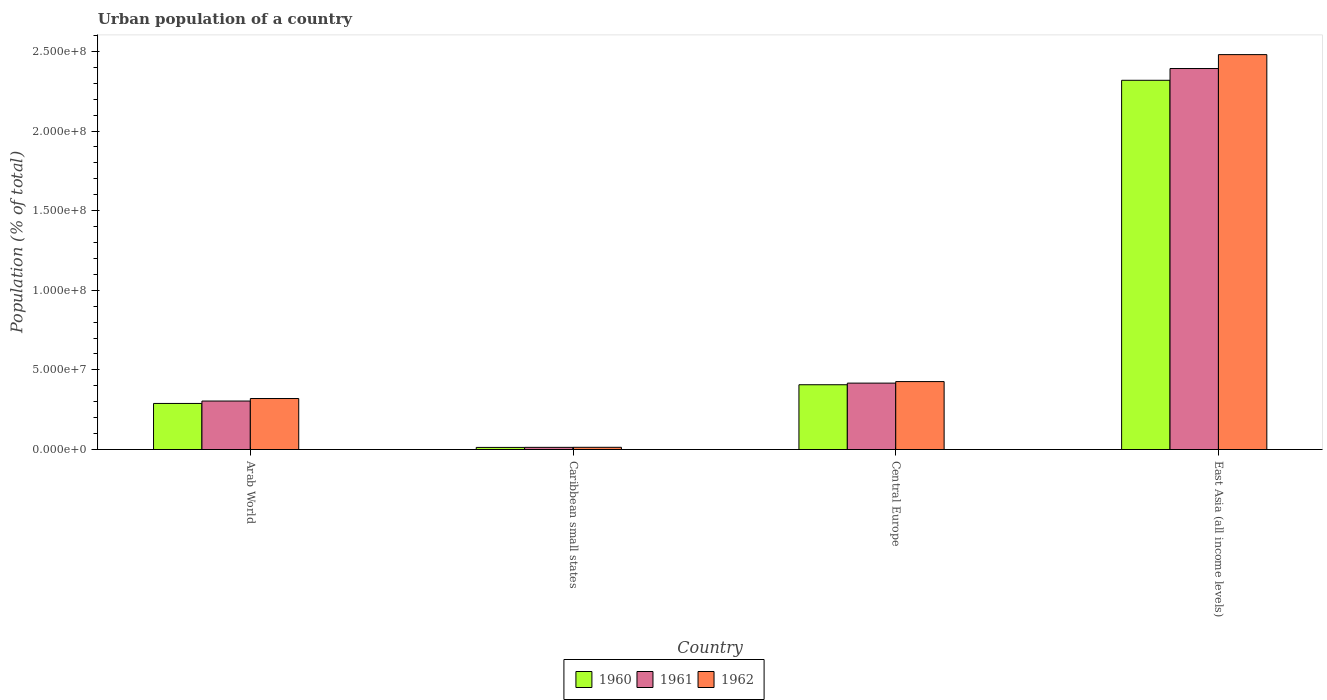How many different coloured bars are there?
Give a very brief answer. 3. How many groups of bars are there?
Your response must be concise. 4. What is the label of the 2nd group of bars from the left?
Offer a very short reply. Caribbean small states. In how many cases, is the number of bars for a given country not equal to the number of legend labels?
Your answer should be very brief. 0. What is the urban population in 1961 in East Asia (all income levels)?
Ensure brevity in your answer.  2.39e+08. Across all countries, what is the maximum urban population in 1962?
Your answer should be very brief. 2.48e+08. Across all countries, what is the minimum urban population in 1962?
Your response must be concise. 1.40e+06. In which country was the urban population in 1962 maximum?
Your answer should be compact. East Asia (all income levels). In which country was the urban population in 1961 minimum?
Your answer should be very brief. Caribbean small states. What is the total urban population in 1962 in the graph?
Provide a short and direct response. 3.24e+08. What is the difference between the urban population in 1960 in Arab World and that in East Asia (all income levels)?
Keep it short and to the point. -2.03e+08. What is the difference between the urban population in 1960 in Central Europe and the urban population in 1961 in Arab World?
Your response must be concise. 1.02e+07. What is the average urban population in 1961 per country?
Ensure brevity in your answer.  7.82e+07. What is the difference between the urban population of/in 1961 and urban population of/in 1962 in East Asia (all income levels)?
Your response must be concise. -8.73e+06. In how many countries, is the urban population in 1961 greater than 30000000 %?
Make the answer very short. 3. What is the ratio of the urban population in 1961 in Arab World to that in Central Europe?
Your response must be concise. 0.73. Is the difference between the urban population in 1961 in Arab World and Central Europe greater than the difference between the urban population in 1962 in Arab World and Central Europe?
Your answer should be very brief. No. What is the difference between the highest and the second highest urban population in 1961?
Keep it short and to the point. -1.13e+07. What is the difference between the highest and the lowest urban population in 1961?
Offer a very short reply. 2.38e+08. Is the sum of the urban population in 1960 in Arab World and East Asia (all income levels) greater than the maximum urban population in 1961 across all countries?
Your response must be concise. Yes. What does the 3rd bar from the right in Arab World represents?
Your response must be concise. 1960. Are all the bars in the graph horizontal?
Give a very brief answer. No. What is the difference between two consecutive major ticks on the Y-axis?
Provide a succinct answer. 5.00e+07. Are the values on the major ticks of Y-axis written in scientific E-notation?
Offer a very short reply. Yes. Does the graph contain grids?
Give a very brief answer. No. Where does the legend appear in the graph?
Your answer should be compact. Bottom center. What is the title of the graph?
Your answer should be very brief. Urban population of a country. What is the label or title of the Y-axis?
Your answer should be compact. Population (% of total). What is the Population (% of total) of 1960 in Arab World?
Provide a succinct answer. 2.89e+07. What is the Population (% of total) of 1961 in Arab World?
Offer a very short reply. 3.04e+07. What is the Population (% of total) of 1962 in Arab World?
Offer a terse response. 3.20e+07. What is the Population (% of total) in 1960 in Caribbean small states?
Your response must be concise. 1.32e+06. What is the Population (% of total) in 1961 in Caribbean small states?
Ensure brevity in your answer.  1.36e+06. What is the Population (% of total) in 1962 in Caribbean small states?
Make the answer very short. 1.40e+06. What is the Population (% of total) of 1960 in Central Europe?
Ensure brevity in your answer.  4.07e+07. What is the Population (% of total) of 1961 in Central Europe?
Your answer should be compact. 4.17e+07. What is the Population (% of total) of 1962 in Central Europe?
Keep it short and to the point. 4.27e+07. What is the Population (% of total) in 1960 in East Asia (all income levels)?
Offer a terse response. 2.32e+08. What is the Population (% of total) in 1961 in East Asia (all income levels)?
Provide a succinct answer. 2.39e+08. What is the Population (% of total) in 1962 in East Asia (all income levels)?
Make the answer very short. 2.48e+08. Across all countries, what is the maximum Population (% of total) of 1960?
Provide a succinct answer. 2.32e+08. Across all countries, what is the maximum Population (% of total) in 1961?
Ensure brevity in your answer.  2.39e+08. Across all countries, what is the maximum Population (% of total) of 1962?
Offer a terse response. 2.48e+08. Across all countries, what is the minimum Population (% of total) of 1960?
Provide a short and direct response. 1.32e+06. Across all countries, what is the minimum Population (% of total) of 1961?
Give a very brief answer. 1.36e+06. Across all countries, what is the minimum Population (% of total) of 1962?
Give a very brief answer. 1.40e+06. What is the total Population (% of total) of 1960 in the graph?
Make the answer very short. 3.03e+08. What is the total Population (% of total) in 1961 in the graph?
Offer a very short reply. 3.13e+08. What is the total Population (% of total) in 1962 in the graph?
Give a very brief answer. 3.24e+08. What is the difference between the Population (% of total) of 1960 in Arab World and that in Caribbean small states?
Provide a short and direct response. 2.76e+07. What is the difference between the Population (% of total) of 1961 in Arab World and that in Caribbean small states?
Ensure brevity in your answer.  2.91e+07. What is the difference between the Population (% of total) in 1962 in Arab World and that in Caribbean small states?
Your response must be concise. 3.06e+07. What is the difference between the Population (% of total) in 1960 in Arab World and that in Central Europe?
Ensure brevity in your answer.  -1.17e+07. What is the difference between the Population (% of total) of 1961 in Arab World and that in Central Europe?
Offer a very short reply. -1.13e+07. What is the difference between the Population (% of total) of 1962 in Arab World and that in Central Europe?
Your answer should be compact. -1.06e+07. What is the difference between the Population (% of total) of 1960 in Arab World and that in East Asia (all income levels)?
Give a very brief answer. -2.03e+08. What is the difference between the Population (% of total) of 1961 in Arab World and that in East Asia (all income levels)?
Provide a short and direct response. -2.09e+08. What is the difference between the Population (% of total) of 1962 in Arab World and that in East Asia (all income levels)?
Ensure brevity in your answer.  -2.16e+08. What is the difference between the Population (% of total) of 1960 in Caribbean small states and that in Central Europe?
Keep it short and to the point. -3.94e+07. What is the difference between the Population (% of total) of 1961 in Caribbean small states and that in Central Europe?
Your answer should be compact. -4.03e+07. What is the difference between the Population (% of total) in 1962 in Caribbean small states and that in Central Europe?
Offer a very short reply. -4.13e+07. What is the difference between the Population (% of total) of 1960 in Caribbean small states and that in East Asia (all income levels)?
Offer a very short reply. -2.31e+08. What is the difference between the Population (% of total) in 1961 in Caribbean small states and that in East Asia (all income levels)?
Keep it short and to the point. -2.38e+08. What is the difference between the Population (% of total) in 1962 in Caribbean small states and that in East Asia (all income levels)?
Give a very brief answer. -2.47e+08. What is the difference between the Population (% of total) of 1960 in Central Europe and that in East Asia (all income levels)?
Give a very brief answer. -1.91e+08. What is the difference between the Population (% of total) of 1961 in Central Europe and that in East Asia (all income levels)?
Keep it short and to the point. -1.98e+08. What is the difference between the Population (% of total) in 1962 in Central Europe and that in East Asia (all income levels)?
Provide a short and direct response. -2.05e+08. What is the difference between the Population (% of total) in 1960 in Arab World and the Population (% of total) in 1961 in Caribbean small states?
Make the answer very short. 2.76e+07. What is the difference between the Population (% of total) of 1960 in Arab World and the Population (% of total) of 1962 in Caribbean small states?
Ensure brevity in your answer.  2.75e+07. What is the difference between the Population (% of total) of 1961 in Arab World and the Population (% of total) of 1962 in Caribbean small states?
Offer a very short reply. 2.90e+07. What is the difference between the Population (% of total) in 1960 in Arab World and the Population (% of total) in 1961 in Central Europe?
Provide a short and direct response. -1.28e+07. What is the difference between the Population (% of total) of 1960 in Arab World and the Population (% of total) of 1962 in Central Europe?
Your answer should be compact. -1.37e+07. What is the difference between the Population (% of total) in 1961 in Arab World and the Population (% of total) in 1962 in Central Europe?
Provide a short and direct response. -1.22e+07. What is the difference between the Population (% of total) in 1960 in Arab World and the Population (% of total) in 1961 in East Asia (all income levels)?
Offer a very short reply. -2.10e+08. What is the difference between the Population (% of total) of 1960 in Arab World and the Population (% of total) of 1962 in East Asia (all income levels)?
Provide a succinct answer. -2.19e+08. What is the difference between the Population (% of total) of 1961 in Arab World and the Population (% of total) of 1962 in East Asia (all income levels)?
Offer a very short reply. -2.18e+08. What is the difference between the Population (% of total) in 1960 in Caribbean small states and the Population (% of total) in 1961 in Central Europe?
Your response must be concise. -4.04e+07. What is the difference between the Population (% of total) in 1960 in Caribbean small states and the Population (% of total) in 1962 in Central Europe?
Offer a terse response. -4.13e+07. What is the difference between the Population (% of total) of 1961 in Caribbean small states and the Population (% of total) of 1962 in Central Europe?
Offer a very short reply. -4.13e+07. What is the difference between the Population (% of total) of 1960 in Caribbean small states and the Population (% of total) of 1961 in East Asia (all income levels)?
Give a very brief answer. -2.38e+08. What is the difference between the Population (% of total) in 1960 in Caribbean small states and the Population (% of total) in 1962 in East Asia (all income levels)?
Provide a succinct answer. -2.47e+08. What is the difference between the Population (% of total) in 1961 in Caribbean small states and the Population (% of total) in 1962 in East Asia (all income levels)?
Give a very brief answer. -2.47e+08. What is the difference between the Population (% of total) of 1960 in Central Europe and the Population (% of total) of 1961 in East Asia (all income levels)?
Offer a terse response. -1.99e+08. What is the difference between the Population (% of total) of 1960 in Central Europe and the Population (% of total) of 1962 in East Asia (all income levels)?
Provide a short and direct response. -2.07e+08. What is the difference between the Population (% of total) in 1961 in Central Europe and the Population (% of total) in 1962 in East Asia (all income levels)?
Provide a succinct answer. -2.06e+08. What is the average Population (% of total) in 1960 per country?
Your response must be concise. 7.57e+07. What is the average Population (% of total) in 1961 per country?
Make the answer very short. 7.82e+07. What is the average Population (% of total) of 1962 per country?
Offer a very short reply. 8.10e+07. What is the difference between the Population (% of total) of 1960 and Population (% of total) of 1961 in Arab World?
Offer a terse response. -1.50e+06. What is the difference between the Population (% of total) in 1960 and Population (% of total) in 1962 in Arab World?
Provide a succinct answer. -3.09e+06. What is the difference between the Population (% of total) of 1961 and Population (% of total) of 1962 in Arab World?
Your response must be concise. -1.58e+06. What is the difference between the Population (% of total) in 1960 and Population (% of total) in 1961 in Caribbean small states?
Ensure brevity in your answer.  -3.48e+04. What is the difference between the Population (% of total) of 1960 and Population (% of total) of 1962 in Caribbean small states?
Ensure brevity in your answer.  -7.14e+04. What is the difference between the Population (% of total) in 1961 and Population (% of total) in 1962 in Caribbean small states?
Offer a terse response. -3.66e+04. What is the difference between the Population (% of total) of 1960 and Population (% of total) of 1961 in Central Europe?
Your response must be concise. -1.02e+06. What is the difference between the Population (% of total) in 1960 and Population (% of total) in 1962 in Central Europe?
Your answer should be very brief. -1.98e+06. What is the difference between the Population (% of total) in 1961 and Population (% of total) in 1962 in Central Europe?
Keep it short and to the point. -9.65e+05. What is the difference between the Population (% of total) of 1960 and Population (% of total) of 1961 in East Asia (all income levels)?
Provide a short and direct response. -7.39e+06. What is the difference between the Population (% of total) in 1960 and Population (% of total) in 1962 in East Asia (all income levels)?
Provide a succinct answer. -1.61e+07. What is the difference between the Population (% of total) in 1961 and Population (% of total) in 1962 in East Asia (all income levels)?
Your answer should be compact. -8.73e+06. What is the ratio of the Population (% of total) in 1960 in Arab World to that in Caribbean small states?
Your answer should be compact. 21.85. What is the ratio of the Population (% of total) in 1961 in Arab World to that in Caribbean small states?
Provide a succinct answer. 22.4. What is the ratio of the Population (% of total) in 1962 in Arab World to that in Caribbean small states?
Your answer should be very brief. 22.95. What is the ratio of the Population (% of total) of 1960 in Arab World to that in Central Europe?
Your response must be concise. 0.71. What is the ratio of the Population (% of total) in 1961 in Arab World to that in Central Europe?
Offer a very short reply. 0.73. What is the ratio of the Population (% of total) in 1962 in Arab World to that in Central Europe?
Your response must be concise. 0.75. What is the ratio of the Population (% of total) in 1960 in Arab World to that in East Asia (all income levels)?
Provide a short and direct response. 0.12. What is the ratio of the Population (% of total) of 1961 in Arab World to that in East Asia (all income levels)?
Your response must be concise. 0.13. What is the ratio of the Population (% of total) of 1962 in Arab World to that in East Asia (all income levels)?
Your answer should be very brief. 0.13. What is the ratio of the Population (% of total) of 1960 in Caribbean small states to that in Central Europe?
Keep it short and to the point. 0.03. What is the ratio of the Population (% of total) in 1961 in Caribbean small states to that in Central Europe?
Your response must be concise. 0.03. What is the ratio of the Population (% of total) of 1962 in Caribbean small states to that in Central Europe?
Your answer should be compact. 0.03. What is the ratio of the Population (% of total) of 1960 in Caribbean small states to that in East Asia (all income levels)?
Provide a succinct answer. 0.01. What is the ratio of the Population (% of total) in 1961 in Caribbean small states to that in East Asia (all income levels)?
Provide a succinct answer. 0.01. What is the ratio of the Population (% of total) in 1962 in Caribbean small states to that in East Asia (all income levels)?
Provide a succinct answer. 0.01. What is the ratio of the Population (% of total) in 1960 in Central Europe to that in East Asia (all income levels)?
Your response must be concise. 0.18. What is the ratio of the Population (% of total) in 1961 in Central Europe to that in East Asia (all income levels)?
Ensure brevity in your answer.  0.17. What is the ratio of the Population (% of total) of 1962 in Central Europe to that in East Asia (all income levels)?
Offer a terse response. 0.17. What is the difference between the highest and the second highest Population (% of total) in 1960?
Offer a terse response. 1.91e+08. What is the difference between the highest and the second highest Population (% of total) of 1961?
Your answer should be very brief. 1.98e+08. What is the difference between the highest and the second highest Population (% of total) of 1962?
Keep it short and to the point. 2.05e+08. What is the difference between the highest and the lowest Population (% of total) of 1960?
Offer a terse response. 2.31e+08. What is the difference between the highest and the lowest Population (% of total) of 1961?
Offer a very short reply. 2.38e+08. What is the difference between the highest and the lowest Population (% of total) in 1962?
Make the answer very short. 2.47e+08. 